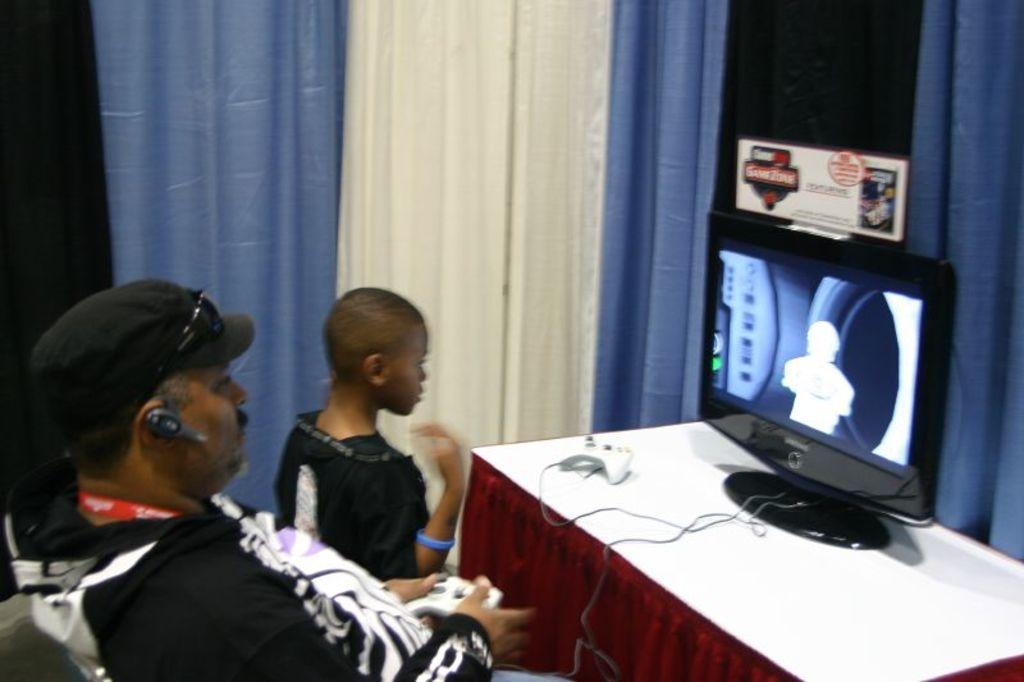How many people are in the image? There are two people in the image, one standing and one sitting. Can you describe the person standing in the image? The person standing is wearing a cap, goggles, and a black jacket. What is on the table in the image? There is a monitor and a remote on the table in the image. What color are the curtains in the image? The curtains are blue and white in color. What type of pump is visible in the image? There is no pump present in the image. Can you tell me how many people are dancing in the club in the image? There is no club or dancing people in the image; it features a person standing and a person sitting. 